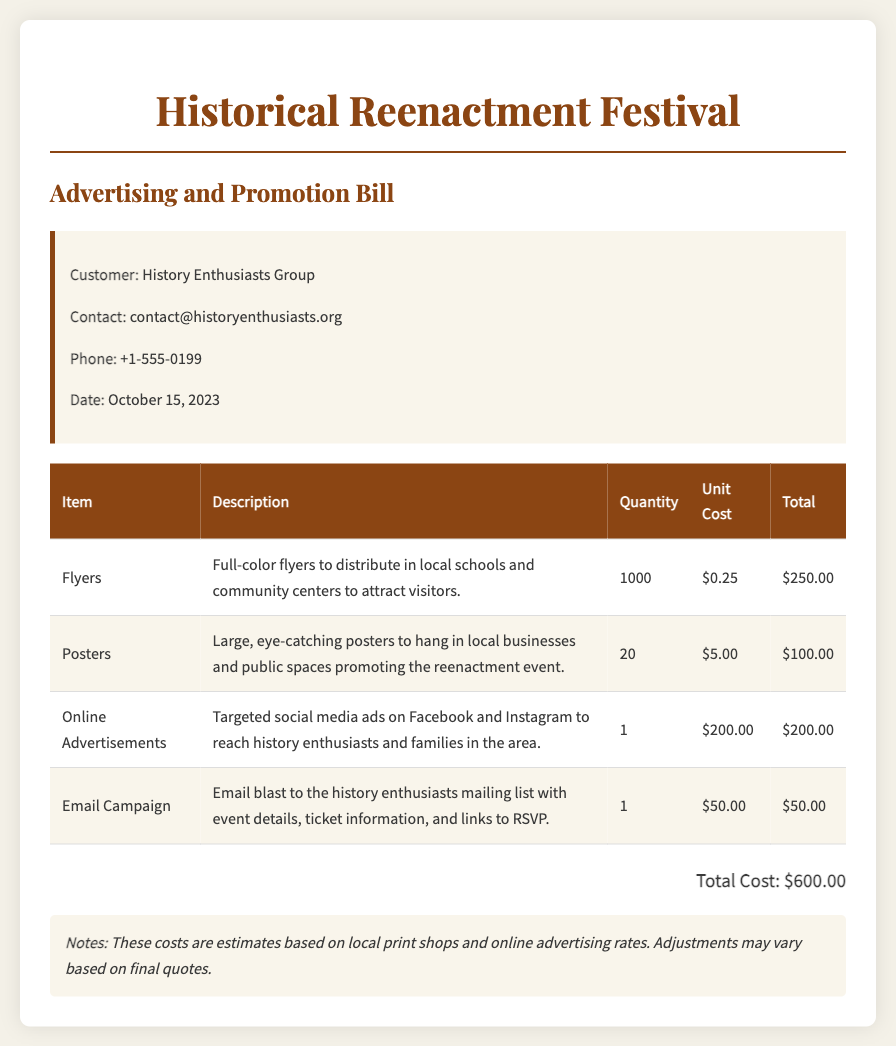What is the total cost of advertising? The total cost is specifically mentioned in the document, which sums up all the individual advertising expenses.
Answer: $600.00 How many flyers are to be printed? The document states the quantity of flyers that are planned for printing in the table section.
Answer: 1000 What is the unit cost of one poster? The unit cost is provided in the table, specifically for the posters used for promotion.
Answer: $5.00 Who is the customer listed in the document? The customer's name is mentioned at the top of the document under customer details.
Answer: History Enthusiasts Group What type of advertisement costs $200? The document specifies which advertising type has this unit cost in the table provided.
Answer: Online Advertisements What is the quantity of email campaigns planned? The email campaign quantity is specified in the table, providing a clear count for this item.
Answer: 1 What is included in the notes section? The notes section contains important information about the cost estimates for the advertising items listed.
Answer: Cost estimates based on local print shops and online advertising rates What is the date of the advertising and promotion bill? The date is explicitly noted in the customer details section of the document.
Answer: October 15, 2023 What is the description of the flyers? The document provides a description of the flyers in the table, explaining their purpose.
Answer: Full-color flyers to distribute in local schools and community centers to attract visitors 